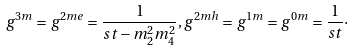Convert formula to latex. <formula><loc_0><loc_0><loc_500><loc_500>g ^ { 3 m } = g ^ { 2 m e } = \frac { 1 } { s t - m _ { 2 } ^ { 2 } m _ { 4 } ^ { 2 } } , g ^ { 2 m h } = g ^ { 1 m } = g ^ { 0 m } = \frac { 1 } { s t } \cdot</formula> 